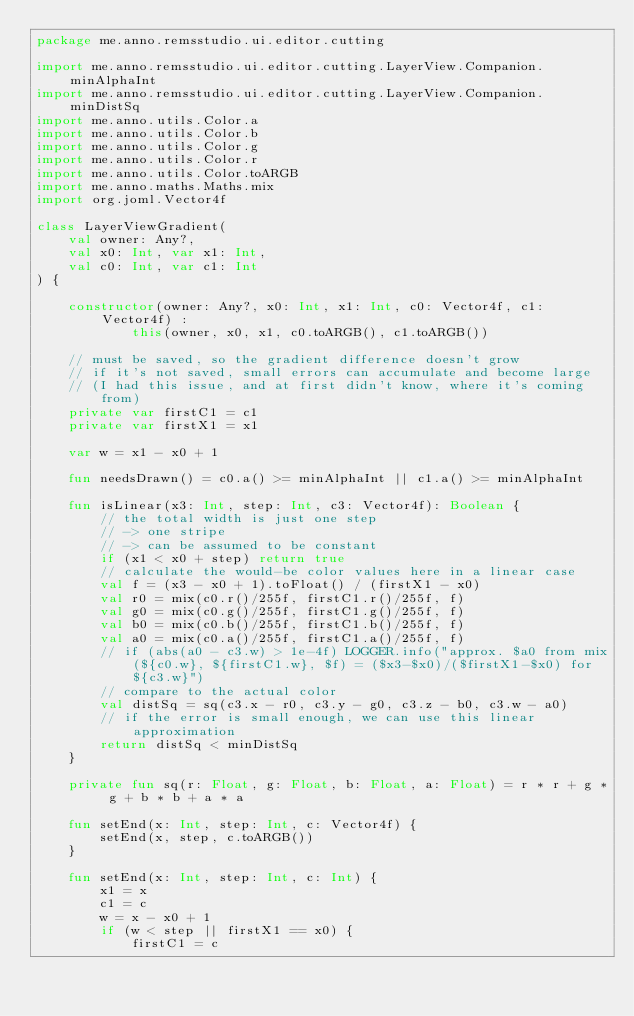Convert code to text. <code><loc_0><loc_0><loc_500><loc_500><_Kotlin_>package me.anno.remsstudio.ui.editor.cutting

import me.anno.remsstudio.ui.editor.cutting.LayerView.Companion.minAlphaInt
import me.anno.remsstudio.ui.editor.cutting.LayerView.Companion.minDistSq
import me.anno.utils.Color.a
import me.anno.utils.Color.b
import me.anno.utils.Color.g
import me.anno.utils.Color.r
import me.anno.utils.Color.toARGB
import me.anno.maths.Maths.mix
import org.joml.Vector4f

class LayerViewGradient(
    val owner: Any?,
    val x0: Int, var x1: Int,
    val c0: Int, var c1: Int
) {

    constructor(owner: Any?, x0: Int, x1: Int, c0: Vector4f, c1: Vector4f) :
            this(owner, x0, x1, c0.toARGB(), c1.toARGB())

    // must be saved, so the gradient difference doesn't grow
    // if it's not saved, small errors can accumulate and become large
    // (I had this issue, and at first didn't know, where it's coming from)
    private var firstC1 = c1
    private var firstX1 = x1

    var w = x1 - x0 + 1

    fun needsDrawn() = c0.a() >= minAlphaInt || c1.a() >= minAlphaInt

    fun isLinear(x3: Int, step: Int, c3: Vector4f): Boolean {
        // the total width is just one step
        // -> one stripe
        // -> can be assumed to be constant
        if (x1 < x0 + step) return true
        // calculate the would-be color values here in a linear case
        val f = (x3 - x0 + 1).toFloat() / (firstX1 - x0)
        val r0 = mix(c0.r()/255f, firstC1.r()/255f, f)
        val g0 = mix(c0.g()/255f, firstC1.g()/255f, f)
        val b0 = mix(c0.b()/255f, firstC1.b()/255f, f)
        val a0 = mix(c0.a()/255f, firstC1.a()/255f, f)
        // if (abs(a0 - c3.w) > 1e-4f) LOGGER.info("approx. $a0 from mix(${c0.w}, ${firstC1.w}, $f) = ($x3-$x0)/($firstX1-$x0) for ${c3.w}")
        // compare to the actual color
        val distSq = sq(c3.x - r0, c3.y - g0, c3.z - b0, c3.w - a0)
        // if the error is small enough, we can use this linear approximation
        return distSq < minDistSq
    }

    private fun sq(r: Float, g: Float, b: Float, a: Float) = r * r + g * g + b * b + a * a

    fun setEnd(x: Int, step: Int, c: Vector4f) {
        setEnd(x, step, c.toARGB())
    }

    fun setEnd(x: Int, step: Int, c: Int) {
        x1 = x
        c1 = c
        w = x - x0 + 1
        if (w < step || firstX1 == x0) {
            firstC1 = c</code> 